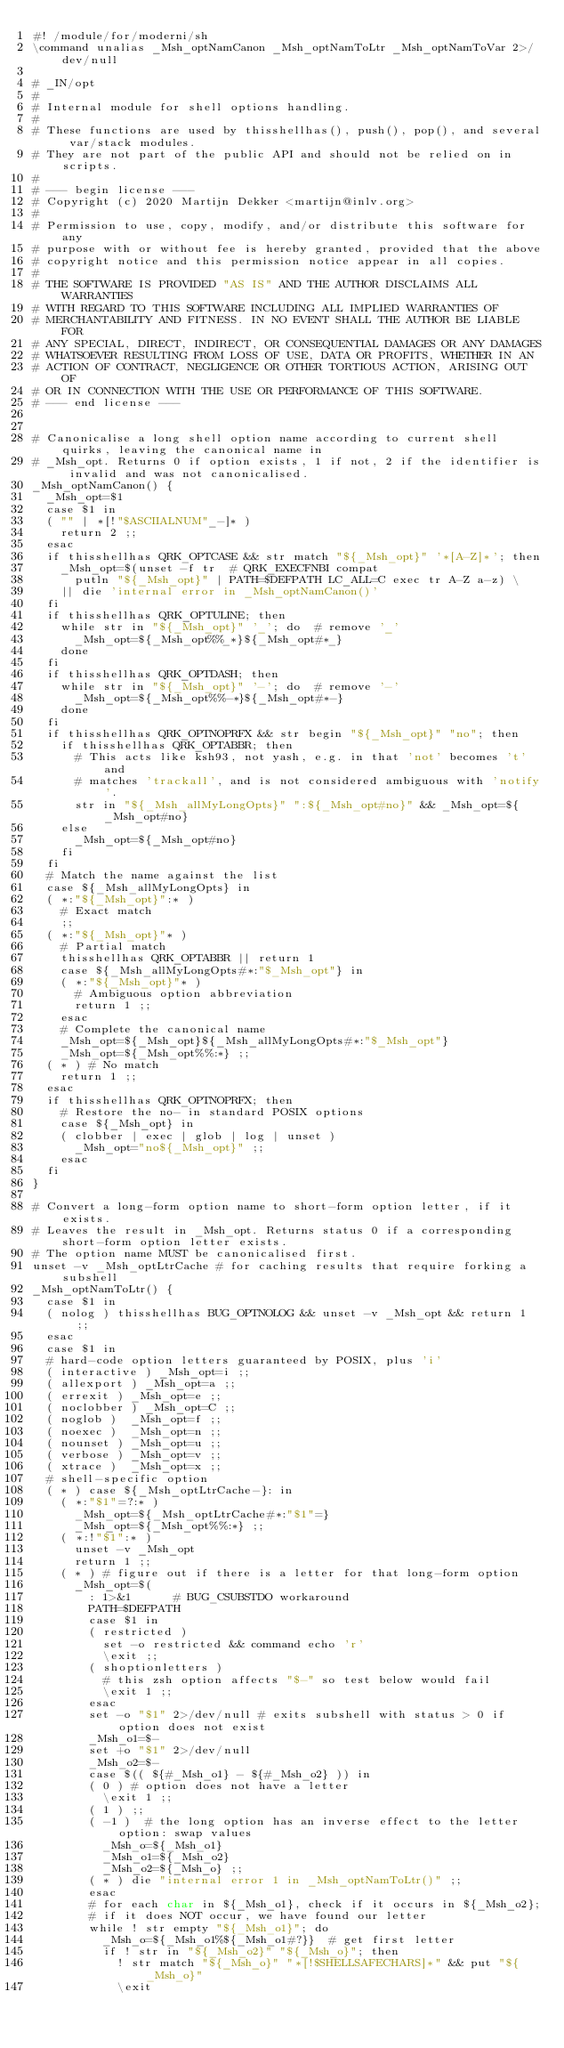Convert code to text. <code><loc_0><loc_0><loc_500><loc_500><_ObjectiveC_>#! /module/for/moderni/sh
\command unalias _Msh_optNamCanon _Msh_optNamToLtr _Msh_optNamToVar 2>/dev/null

# _IN/opt
#
# Internal module for shell options handling.
#
# These functions are used by thisshellhas(), push(), pop(), and several var/stack modules.
# They are not part of the public API and should not be relied on in scripts.
#
# --- begin license ---
# Copyright (c) 2020 Martijn Dekker <martijn@inlv.org>
#
# Permission to use, copy, modify, and/or distribute this software for any
# purpose with or without fee is hereby granted, provided that the above
# copyright notice and this permission notice appear in all copies.
#
# THE SOFTWARE IS PROVIDED "AS IS" AND THE AUTHOR DISCLAIMS ALL WARRANTIES
# WITH REGARD TO THIS SOFTWARE INCLUDING ALL IMPLIED WARRANTIES OF
# MERCHANTABILITY AND FITNESS. IN NO EVENT SHALL THE AUTHOR BE LIABLE FOR
# ANY SPECIAL, DIRECT, INDIRECT, OR CONSEQUENTIAL DAMAGES OR ANY DAMAGES
# WHATSOEVER RESULTING FROM LOSS OF USE, DATA OR PROFITS, WHETHER IN AN
# ACTION OF CONTRACT, NEGLIGENCE OR OTHER TORTIOUS ACTION, ARISING OUT OF
# OR IN CONNECTION WITH THE USE OR PERFORMANCE OF THIS SOFTWARE.
# --- end license ---


# Canonicalise a long shell option name according to current shell quirks, leaving the canonical name in
# _Msh_opt. Returns 0 if option exists, 1 if not, 2 if the identifier is invalid and was not canonicalised.
_Msh_optNamCanon() {
	_Msh_opt=$1
	case $1 in
	( "" | *[!"$ASCIIALNUM"_-]* )
		return 2 ;;
	esac
	if thisshellhas QRK_OPTCASE && str match "${_Msh_opt}" '*[A-Z]*'; then
		_Msh_opt=$(unset -f tr	# QRK_EXECFNBI compat
			putln "${_Msh_opt}" | PATH=$DEFPATH LC_ALL=C exec tr A-Z a-z) \
		|| die 'internal error in _Msh_optNamCanon()'
	fi
	if thisshellhas QRK_OPTULINE; then
		while str in "${_Msh_opt}" '_'; do	# remove '_'
			_Msh_opt=${_Msh_opt%%_*}${_Msh_opt#*_}
		done
	fi
	if thisshellhas QRK_OPTDASH; then
		while str in "${_Msh_opt}" '-'; do	# remove '-'
			_Msh_opt=${_Msh_opt%%-*}${_Msh_opt#*-}
		done
	fi
	if thisshellhas QRK_OPTNOPRFX && str begin "${_Msh_opt}" "no"; then
		if thisshellhas QRK_OPTABBR; then
			# This acts like ksh93, not yash, e.g. in that 'not' becomes 't' and
			# matches 'trackall', and is not considered ambiguous with 'notify'.
			str in "${_Msh_allMyLongOpts}" ":${_Msh_opt#no}" && _Msh_opt=${_Msh_opt#no}
		else
			_Msh_opt=${_Msh_opt#no}
		fi
	fi
	# Match the name against the list
	case ${_Msh_allMyLongOpts} in
	( *:"${_Msh_opt}":* )
		# Exact match
		;;
	( *:"${_Msh_opt}"* )
		# Partial match
		thisshellhas QRK_OPTABBR || return 1
		case ${_Msh_allMyLongOpts#*:"$_Msh_opt"} in
		( *:"${_Msh_opt}"* )
			# Ambiguous option abbreviation
			return 1 ;;
		esac
		# Complete the canonical name
		_Msh_opt=${_Msh_opt}${_Msh_allMyLongOpts#*:"$_Msh_opt"}
		_Msh_opt=${_Msh_opt%%:*} ;;
	( * )	# No match
		return 1 ;;
	esac
	if thisshellhas QRK_OPTNOPRFX; then
		# Restore the no- in standard POSIX options
		case ${_Msh_opt} in
		( clobber | exec | glob | log | unset )
			_Msh_opt="no${_Msh_opt}" ;;
		esac
	fi
}

# Convert a long-form option name to short-form option letter, if it exists.
# Leaves the result in _Msh_opt. Returns status 0 if a corresponding short-form option letter exists.
# The option name MUST be canonicalised first.
unset -v _Msh_optLtrCache	# for caching results that require forking a subshell
_Msh_optNamToLtr() {
	case $1 in
	( nolog )	thisshellhas BUG_OPTNOLOG && unset -v _Msh_opt && return 1 ;;
	esac
	case $1 in
	# hard-code option letters guaranteed by POSIX, plus 'i'
	( interactive )	_Msh_opt=i ;;
	( allexport )	_Msh_opt=a ;;
	( errexit )	_Msh_opt=e ;;
	( noclobber )	_Msh_opt=C ;;
	( noglob )	_Msh_opt=f ;;
	( noexec )	_Msh_opt=n ;;
	( nounset )	_Msh_opt=u ;;
	( verbose )	_Msh_opt=v ;;
	( xtrace )	_Msh_opt=x ;;
	# shell-specific option
	( * )	case ${_Msh_optLtrCache-}: in
		( *:"$1"=?:* )
			_Msh_opt=${_Msh_optLtrCache#*:"$1"=}
			_Msh_opt=${_Msh_opt%%:*} ;;
		( *:!"$1":* )
			unset -v _Msh_opt
			return 1 ;;
		( * )	# figure out if there is a letter for that long-form option
			_Msh_opt=$(
				: 1>&1			# BUG_CSUBSTDO workaround
				PATH=$DEFPATH
				case $1 in
				( restricted )
					set -o restricted && command echo 'r'
					\exit ;;
				( shoptionletters )
					# this zsh option affects "$-" so test below would fail
					\exit 1 ;;
				esac
				set -o "$1" 2>/dev/null	# exits subshell with status > 0 if option does not exist
				_Msh_o1=$-
				set +o "$1" 2>/dev/null
				_Msh_o2=$-
				case $(( ${#_Msh_o1} - ${#_Msh_o2} )) in
				( 0 )	# option does not have a letter
					\exit 1 ;;
				( 1 )	;;
				( -1 )	# the long option has an inverse effect to the letter option: swap values
					_Msh_o=${_Msh_o1}
					_Msh_o1=${_Msh_o2}
					_Msh_o2=${_Msh_o} ;;
				( * )	die "internal error 1 in _Msh_optNamToLtr()" ;;
				esac
				# for each char in ${_Msh_o1}, check if it occurs in ${_Msh_o2};
				# if it does NOT occur, we have found our letter
				while ! str empty "${_Msh_o1}"; do
					_Msh_o=${_Msh_o1%${_Msh_o1#?}}	# get first letter
					if ! str in "${_Msh_o2}" "${_Msh_o}"; then
						! str match "${_Msh_o}" "*[!$SHELLSAFECHARS]*" && put "${_Msh_o}"
						\exit</code> 